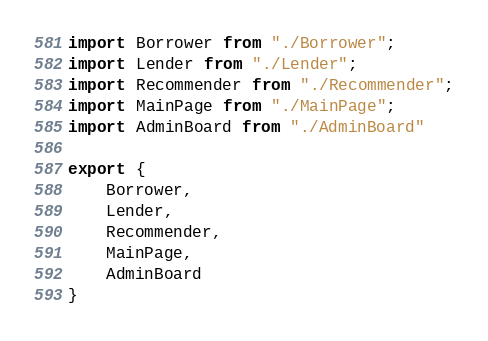Convert code to text. <code><loc_0><loc_0><loc_500><loc_500><_JavaScript_>import Borrower from "./Borrower";
import Lender from "./Lender";
import Recommender from "./Recommender";
import MainPage from "./MainPage";
import AdminBoard from "./AdminBoard"

export {
    Borrower,
    Lender,
    Recommender,
    MainPage,
    AdminBoard
}
</code> 